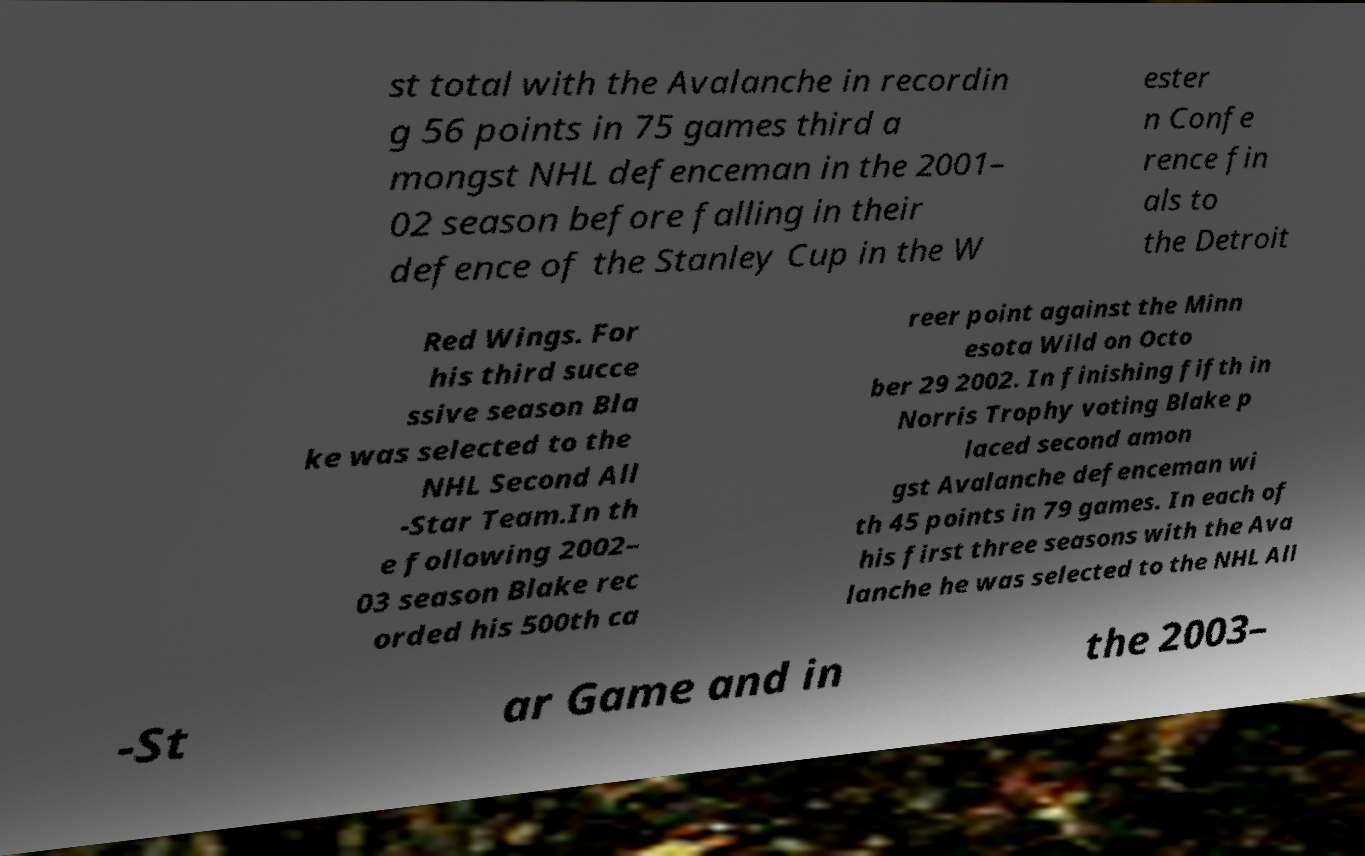I need the written content from this picture converted into text. Can you do that? st total with the Avalanche in recordin g 56 points in 75 games third a mongst NHL defenceman in the 2001– 02 season before falling in their defence of the Stanley Cup in the W ester n Confe rence fin als to the Detroit Red Wings. For his third succe ssive season Bla ke was selected to the NHL Second All -Star Team.In th e following 2002– 03 season Blake rec orded his 500th ca reer point against the Minn esota Wild on Octo ber 29 2002. In finishing fifth in Norris Trophy voting Blake p laced second amon gst Avalanche defenceman wi th 45 points in 79 games. In each of his first three seasons with the Ava lanche he was selected to the NHL All -St ar Game and in the 2003– 